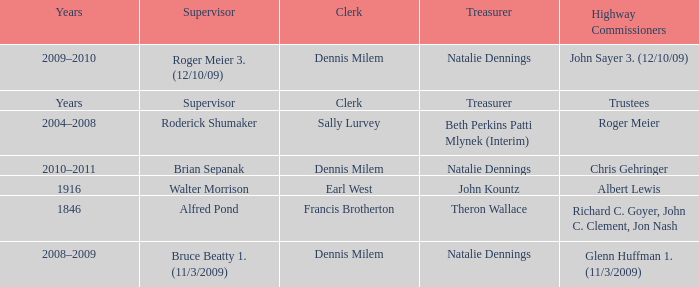Who was the clerk when the highway commissioner was Albert Lewis? Earl West. 